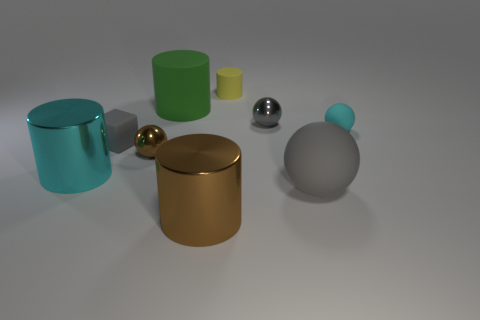Can you describe the colors and materials of the objects presented? Certainly! Among the objects, there are two cylinders – one small yellow with a rubber-like texture and a larger green with a matte finish, a golden spherical object with a reflective metallic surface, a silver sphere that also appears metallic, and a grey cylinder with a blue top that seems to have a rubbery texture.  Which object stands out the most? The golden sphere stands out due to its reflective metallic finish and the way it contrasts with the matte surfaces of the other objects. 